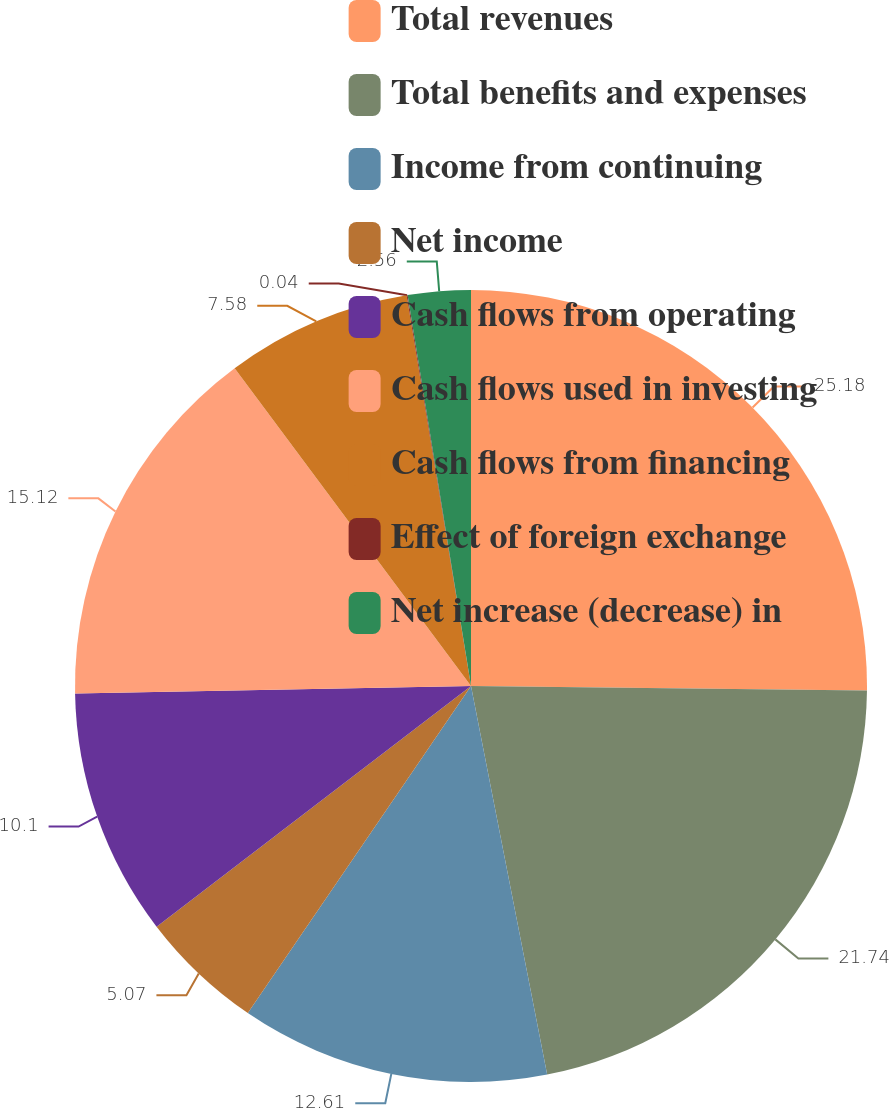Convert chart to OTSL. <chart><loc_0><loc_0><loc_500><loc_500><pie_chart><fcel>Total revenues<fcel>Total benefits and expenses<fcel>Income from continuing<fcel>Net income<fcel>Cash flows from operating<fcel>Cash flows used in investing<fcel>Cash flows from financing<fcel>Effect of foreign exchange<fcel>Net increase (decrease) in<nl><fcel>25.18%<fcel>21.74%<fcel>12.61%<fcel>5.07%<fcel>10.1%<fcel>15.12%<fcel>7.58%<fcel>0.04%<fcel>2.56%<nl></chart> 